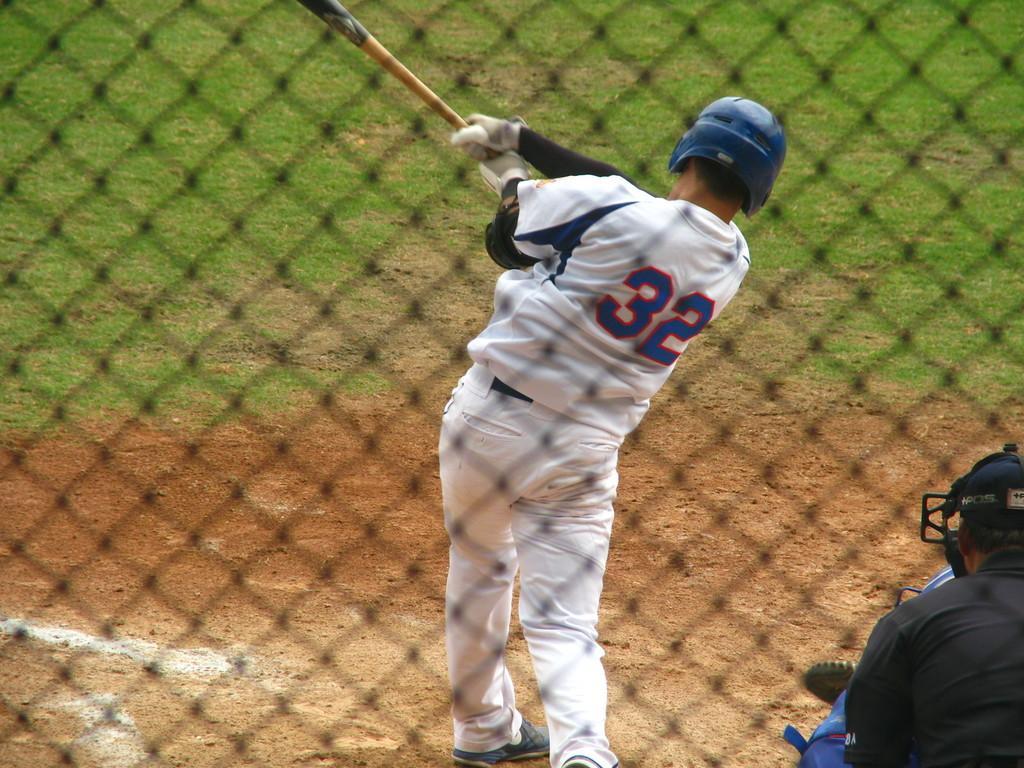Can you describe this image briefly? In this image in the center there is one person who is standing and he is holding the bat it seems that he is playing, and in the foreground there is net. And at the bottom there is sand and grass and also there are two persons. 